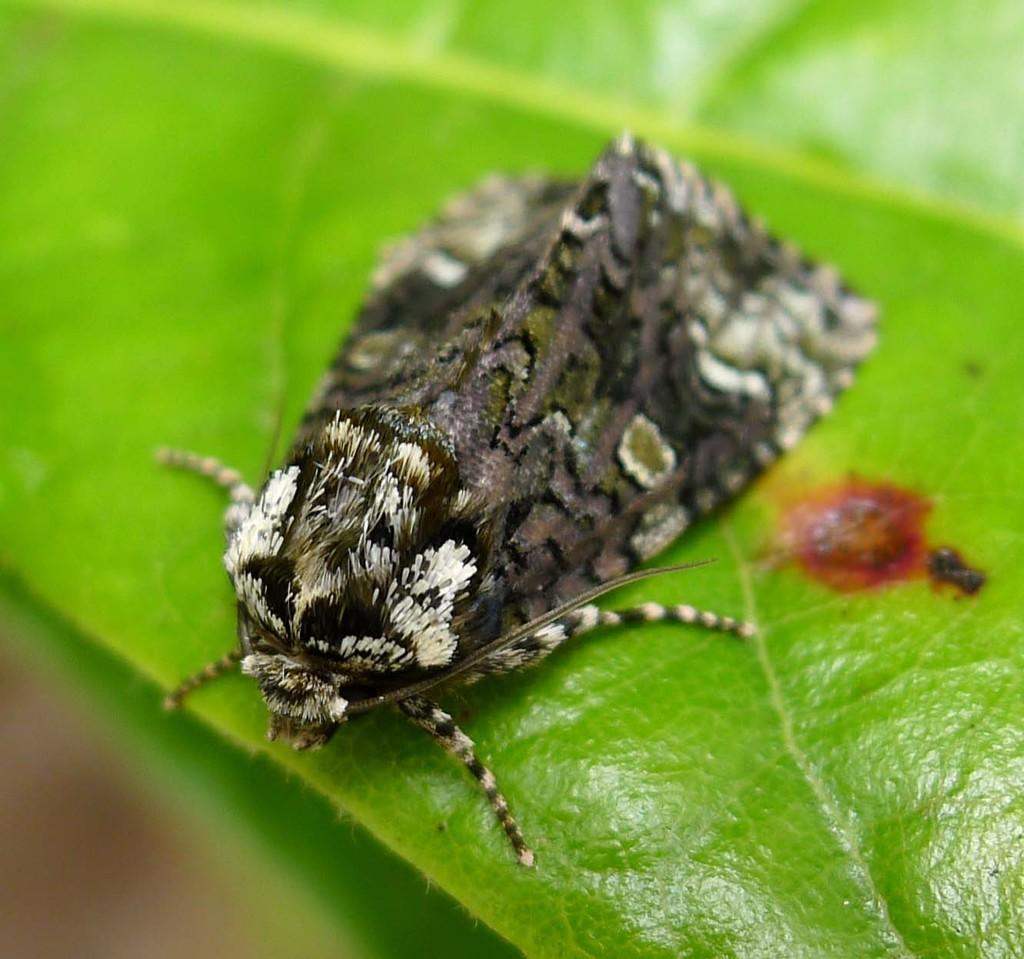What type of creature is present in the image? There is an insect in the image. What colors can be seen on the insect? The insect has black, brown, white, and green colors. Where is the insect located in the image? The insect is on a green leaf. What degree does the insect have in the image? Insects do not have degrees, as they are not capable of obtaining academic qualifications. 